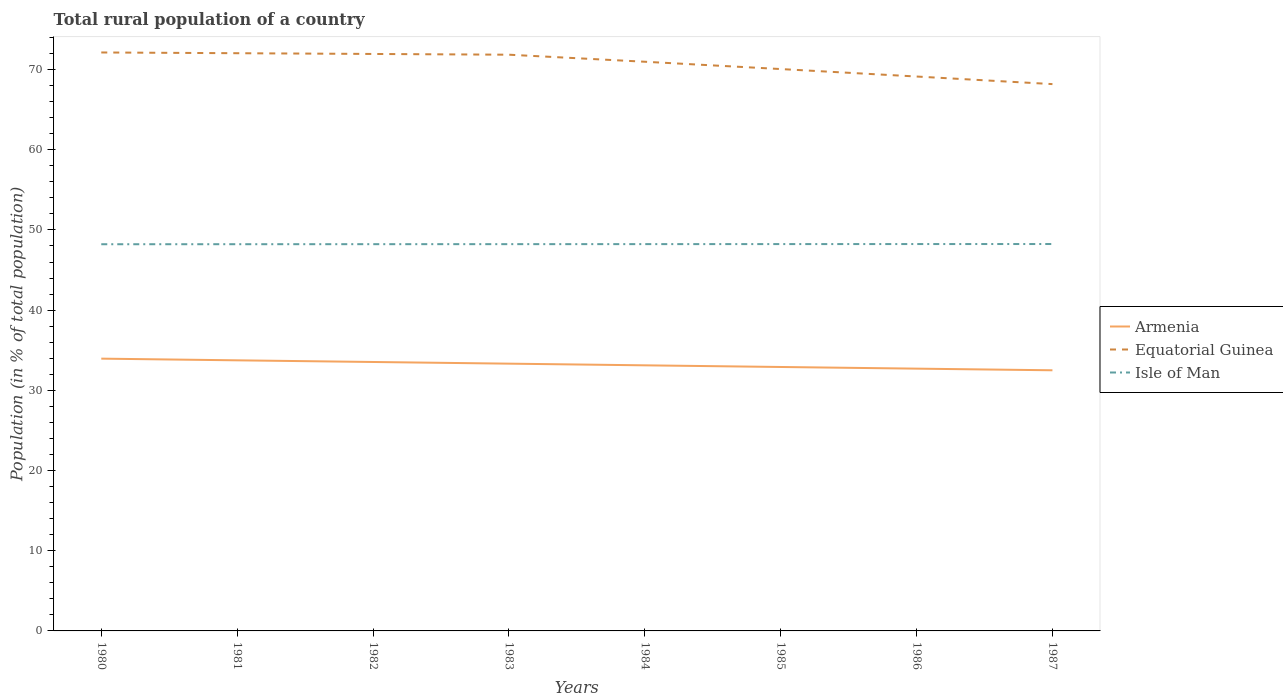How many different coloured lines are there?
Your response must be concise. 3. Does the line corresponding to Isle of Man intersect with the line corresponding to Armenia?
Keep it short and to the point. No. Across all years, what is the maximum rural population in Equatorial Guinea?
Give a very brief answer. 68.18. In which year was the rural population in Armenia maximum?
Your response must be concise. 1987. What is the total rural population in Armenia in the graph?
Your response must be concise. 0.62. What is the difference between the highest and the second highest rural population in Isle of Man?
Your answer should be compact. 0.03. What is the difference between the highest and the lowest rural population in Isle of Man?
Your answer should be very brief. 4. Is the rural population in Equatorial Guinea strictly greater than the rural population in Isle of Man over the years?
Offer a terse response. No. Are the values on the major ticks of Y-axis written in scientific E-notation?
Give a very brief answer. No. Does the graph contain any zero values?
Your answer should be compact. No. Where does the legend appear in the graph?
Your answer should be very brief. Center right. How many legend labels are there?
Provide a short and direct response. 3. How are the legend labels stacked?
Your answer should be very brief. Vertical. What is the title of the graph?
Provide a short and direct response. Total rural population of a country. Does "El Salvador" appear as one of the legend labels in the graph?
Provide a short and direct response. No. What is the label or title of the X-axis?
Provide a succinct answer. Years. What is the label or title of the Y-axis?
Provide a short and direct response. Population (in % of total population). What is the Population (in % of total population) in Armenia in 1980?
Offer a terse response. 33.95. What is the Population (in % of total population) in Equatorial Guinea in 1980?
Your answer should be very brief. 72.13. What is the Population (in % of total population) in Isle of Man in 1980?
Keep it short and to the point. 48.22. What is the Population (in % of total population) in Armenia in 1981?
Ensure brevity in your answer.  33.74. What is the Population (in % of total population) of Equatorial Guinea in 1981?
Provide a succinct answer. 72.03. What is the Population (in % of total population) in Isle of Man in 1981?
Provide a succinct answer. 48.22. What is the Population (in % of total population) of Armenia in 1982?
Offer a terse response. 33.53. What is the Population (in % of total population) of Equatorial Guinea in 1982?
Provide a succinct answer. 71.94. What is the Population (in % of total population) of Isle of Man in 1982?
Your answer should be very brief. 48.22. What is the Population (in % of total population) in Armenia in 1983?
Provide a short and direct response. 33.33. What is the Population (in % of total population) in Equatorial Guinea in 1983?
Offer a terse response. 71.85. What is the Population (in % of total population) of Isle of Man in 1983?
Offer a terse response. 48.23. What is the Population (in % of total population) in Armenia in 1984?
Make the answer very short. 33.12. What is the Population (in % of total population) in Equatorial Guinea in 1984?
Offer a terse response. 70.97. What is the Population (in % of total population) of Isle of Man in 1984?
Your answer should be compact. 48.23. What is the Population (in % of total population) of Armenia in 1985?
Provide a short and direct response. 32.91. What is the Population (in % of total population) in Equatorial Guinea in 1985?
Your response must be concise. 70.06. What is the Population (in % of total population) of Isle of Man in 1985?
Make the answer very short. 48.23. What is the Population (in % of total population) in Armenia in 1986?
Offer a terse response. 32.7. What is the Population (in % of total population) in Equatorial Guinea in 1986?
Make the answer very short. 69.13. What is the Population (in % of total population) of Isle of Man in 1986?
Give a very brief answer. 48.24. What is the Population (in % of total population) in Armenia in 1987?
Offer a very short reply. 32.5. What is the Population (in % of total population) of Equatorial Guinea in 1987?
Your answer should be compact. 68.18. What is the Population (in % of total population) of Isle of Man in 1987?
Make the answer very short. 48.24. Across all years, what is the maximum Population (in % of total population) of Armenia?
Provide a succinct answer. 33.95. Across all years, what is the maximum Population (in % of total population) in Equatorial Guinea?
Offer a terse response. 72.13. Across all years, what is the maximum Population (in % of total population) of Isle of Man?
Make the answer very short. 48.24. Across all years, what is the minimum Population (in % of total population) of Armenia?
Keep it short and to the point. 32.5. Across all years, what is the minimum Population (in % of total population) of Equatorial Guinea?
Your answer should be very brief. 68.18. Across all years, what is the minimum Population (in % of total population) in Isle of Man?
Your answer should be very brief. 48.22. What is the total Population (in % of total population) in Armenia in the graph?
Make the answer very short. 265.78. What is the total Population (in % of total population) in Equatorial Guinea in the graph?
Provide a succinct answer. 566.3. What is the total Population (in % of total population) in Isle of Man in the graph?
Your response must be concise. 385.83. What is the difference between the Population (in % of total population) of Armenia in 1980 and that in 1981?
Your answer should be compact. 0.21. What is the difference between the Population (in % of total population) of Equatorial Guinea in 1980 and that in 1981?
Keep it short and to the point. 0.09. What is the difference between the Population (in % of total population) in Isle of Man in 1980 and that in 1981?
Your response must be concise. -0. What is the difference between the Population (in % of total population) of Armenia in 1980 and that in 1982?
Offer a terse response. 0.42. What is the difference between the Population (in % of total population) of Equatorial Guinea in 1980 and that in 1982?
Your answer should be very brief. 0.19. What is the difference between the Population (in % of total population) in Isle of Man in 1980 and that in 1982?
Provide a succinct answer. -0.01. What is the difference between the Population (in % of total population) of Armenia in 1980 and that in 1983?
Give a very brief answer. 0.62. What is the difference between the Population (in % of total population) of Equatorial Guinea in 1980 and that in 1983?
Your answer should be very brief. 0.28. What is the difference between the Population (in % of total population) in Isle of Man in 1980 and that in 1983?
Your answer should be very brief. -0.01. What is the difference between the Population (in % of total population) in Armenia in 1980 and that in 1984?
Provide a succinct answer. 0.83. What is the difference between the Population (in % of total population) of Equatorial Guinea in 1980 and that in 1984?
Make the answer very short. 1.16. What is the difference between the Population (in % of total population) of Isle of Man in 1980 and that in 1984?
Give a very brief answer. -0.01. What is the difference between the Population (in % of total population) in Armenia in 1980 and that in 1985?
Make the answer very short. 1.04. What is the difference between the Population (in % of total population) of Equatorial Guinea in 1980 and that in 1985?
Your answer should be very brief. 2.07. What is the difference between the Population (in % of total population) in Isle of Man in 1980 and that in 1985?
Give a very brief answer. -0.02. What is the difference between the Population (in % of total population) in Armenia in 1980 and that in 1986?
Offer a terse response. 1.25. What is the difference between the Population (in % of total population) of Equatorial Guinea in 1980 and that in 1986?
Make the answer very short. 3. What is the difference between the Population (in % of total population) in Isle of Man in 1980 and that in 1986?
Your response must be concise. -0.02. What is the difference between the Population (in % of total population) in Armenia in 1980 and that in 1987?
Make the answer very short. 1.45. What is the difference between the Population (in % of total population) in Equatorial Guinea in 1980 and that in 1987?
Your answer should be very brief. 3.94. What is the difference between the Population (in % of total population) of Isle of Man in 1980 and that in 1987?
Make the answer very short. -0.03. What is the difference between the Population (in % of total population) in Armenia in 1981 and that in 1982?
Provide a succinct answer. 0.21. What is the difference between the Population (in % of total population) in Equatorial Guinea in 1981 and that in 1982?
Give a very brief answer. 0.09. What is the difference between the Population (in % of total population) in Isle of Man in 1981 and that in 1982?
Keep it short and to the point. -0. What is the difference between the Population (in % of total population) in Armenia in 1981 and that in 1983?
Ensure brevity in your answer.  0.42. What is the difference between the Population (in % of total population) of Equatorial Guinea in 1981 and that in 1983?
Offer a very short reply. 0.19. What is the difference between the Population (in % of total population) of Isle of Man in 1981 and that in 1983?
Keep it short and to the point. -0.01. What is the difference between the Population (in % of total population) of Armenia in 1981 and that in 1984?
Your answer should be very brief. 0.62. What is the difference between the Population (in % of total population) of Equatorial Guinea in 1981 and that in 1984?
Provide a short and direct response. 1.06. What is the difference between the Population (in % of total population) of Isle of Man in 1981 and that in 1984?
Provide a succinct answer. -0.01. What is the difference between the Population (in % of total population) of Armenia in 1981 and that in 1985?
Your response must be concise. 0.83. What is the difference between the Population (in % of total population) of Equatorial Guinea in 1981 and that in 1985?
Your answer should be very brief. 1.98. What is the difference between the Population (in % of total population) of Isle of Man in 1981 and that in 1985?
Keep it short and to the point. -0.01. What is the difference between the Population (in % of total population) in Armenia in 1981 and that in 1986?
Provide a short and direct response. 1.04. What is the difference between the Population (in % of total population) of Equatorial Guinea in 1981 and that in 1986?
Your answer should be compact. 2.91. What is the difference between the Population (in % of total population) in Isle of Man in 1981 and that in 1986?
Your answer should be compact. -0.02. What is the difference between the Population (in % of total population) in Armenia in 1981 and that in 1987?
Keep it short and to the point. 1.24. What is the difference between the Population (in % of total population) in Equatorial Guinea in 1981 and that in 1987?
Offer a very short reply. 3.85. What is the difference between the Population (in % of total population) in Isle of Man in 1981 and that in 1987?
Provide a succinct answer. -0.02. What is the difference between the Population (in % of total population) of Armenia in 1982 and that in 1983?
Ensure brevity in your answer.  0.21. What is the difference between the Population (in % of total population) in Equatorial Guinea in 1982 and that in 1983?
Your answer should be very brief. 0.09. What is the difference between the Population (in % of total population) in Isle of Man in 1982 and that in 1983?
Offer a very short reply. -0. What is the difference between the Population (in % of total population) of Armenia in 1982 and that in 1984?
Offer a terse response. 0.42. What is the difference between the Population (in % of total population) of Isle of Man in 1982 and that in 1984?
Your answer should be compact. -0.01. What is the difference between the Population (in % of total population) in Armenia in 1982 and that in 1985?
Your answer should be compact. 0.62. What is the difference between the Population (in % of total population) of Equatorial Guinea in 1982 and that in 1985?
Ensure brevity in your answer.  1.88. What is the difference between the Population (in % of total population) in Isle of Man in 1982 and that in 1985?
Your response must be concise. -0.01. What is the difference between the Population (in % of total population) in Armenia in 1982 and that in 1986?
Keep it short and to the point. 0.83. What is the difference between the Population (in % of total population) in Equatorial Guinea in 1982 and that in 1986?
Give a very brief answer. 2.81. What is the difference between the Population (in % of total population) in Isle of Man in 1982 and that in 1986?
Ensure brevity in your answer.  -0.01. What is the difference between the Population (in % of total population) of Armenia in 1982 and that in 1987?
Keep it short and to the point. 1.03. What is the difference between the Population (in % of total population) of Equatorial Guinea in 1982 and that in 1987?
Provide a succinct answer. 3.76. What is the difference between the Population (in % of total population) in Isle of Man in 1982 and that in 1987?
Your response must be concise. -0.02. What is the difference between the Population (in % of total population) of Armenia in 1983 and that in 1984?
Your answer should be very brief. 0.21. What is the difference between the Population (in % of total population) of Equatorial Guinea in 1983 and that in 1984?
Ensure brevity in your answer.  0.88. What is the difference between the Population (in % of total population) in Isle of Man in 1983 and that in 1984?
Your answer should be very brief. -0. What is the difference between the Population (in % of total population) of Armenia in 1983 and that in 1985?
Offer a very short reply. 0.41. What is the difference between the Population (in % of total population) of Equatorial Guinea in 1983 and that in 1985?
Provide a short and direct response. 1.79. What is the difference between the Population (in % of total population) of Isle of Man in 1983 and that in 1985?
Your answer should be very brief. -0.01. What is the difference between the Population (in % of total population) of Armenia in 1983 and that in 1986?
Offer a very short reply. 0.62. What is the difference between the Population (in % of total population) in Equatorial Guinea in 1983 and that in 1986?
Offer a very short reply. 2.72. What is the difference between the Population (in % of total population) of Isle of Man in 1983 and that in 1986?
Your response must be concise. -0.01. What is the difference between the Population (in % of total population) of Armenia in 1983 and that in 1987?
Provide a succinct answer. 0.83. What is the difference between the Population (in % of total population) in Equatorial Guinea in 1983 and that in 1987?
Keep it short and to the point. 3.67. What is the difference between the Population (in % of total population) of Isle of Man in 1983 and that in 1987?
Your answer should be compact. -0.02. What is the difference between the Population (in % of total population) in Armenia in 1984 and that in 1985?
Your answer should be very brief. 0.21. What is the difference between the Population (in % of total population) in Equatorial Guinea in 1984 and that in 1985?
Keep it short and to the point. 0.91. What is the difference between the Population (in % of total population) of Isle of Man in 1984 and that in 1985?
Ensure brevity in your answer.  -0. What is the difference between the Population (in % of total population) in Armenia in 1984 and that in 1986?
Your answer should be very brief. 0.41. What is the difference between the Population (in % of total population) of Equatorial Guinea in 1984 and that in 1986?
Your answer should be very brief. 1.84. What is the difference between the Population (in % of total population) in Isle of Man in 1984 and that in 1986?
Offer a very short reply. -0.01. What is the difference between the Population (in % of total population) of Armenia in 1984 and that in 1987?
Ensure brevity in your answer.  0.62. What is the difference between the Population (in % of total population) in Equatorial Guinea in 1984 and that in 1987?
Keep it short and to the point. 2.79. What is the difference between the Population (in % of total population) of Isle of Man in 1984 and that in 1987?
Give a very brief answer. -0.01. What is the difference between the Population (in % of total population) in Armenia in 1985 and that in 1986?
Offer a very short reply. 0.21. What is the difference between the Population (in % of total population) in Equatorial Guinea in 1985 and that in 1986?
Your answer should be compact. 0.93. What is the difference between the Population (in % of total population) in Isle of Man in 1985 and that in 1986?
Give a very brief answer. -0. What is the difference between the Population (in % of total population) in Armenia in 1985 and that in 1987?
Your answer should be very brief. 0.41. What is the difference between the Population (in % of total population) of Equatorial Guinea in 1985 and that in 1987?
Provide a succinct answer. 1.88. What is the difference between the Population (in % of total population) of Isle of Man in 1985 and that in 1987?
Keep it short and to the point. -0.01. What is the difference between the Population (in % of total population) of Armenia in 1986 and that in 1987?
Your answer should be very brief. 0.2. What is the difference between the Population (in % of total population) in Equatorial Guinea in 1986 and that in 1987?
Ensure brevity in your answer.  0.95. What is the difference between the Population (in % of total population) in Isle of Man in 1986 and that in 1987?
Keep it short and to the point. -0. What is the difference between the Population (in % of total population) of Armenia in 1980 and the Population (in % of total population) of Equatorial Guinea in 1981?
Your response must be concise. -38.09. What is the difference between the Population (in % of total population) in Armenia in 1980 and the Population (in % of total population) in Isle of Man in 1981?
Offer a terse response. -14.27. What is the difference between the Population (in % of total population) of Equatorial Guinea in 1980 and the Population (in % of total population) of Isle of Man in 1981?
Offer a terse response. 23.91. What is the difference between the Population (in % of total population) in Armenia in 1980 and the Population (in % of total population) in Equatorial Guinea in 1982?
Your answer should be compact. -37.99. What is the difference between the Population (in % of total population) of Armenia in 1980 and the Population (in % of total population) of Isle of Man in 1982?
Your response must be concise. -14.27. What is the difference between the Population (in % of total population) of Equatorial Guinea in 1980 and the Population (in % of total population) of Isle of Man in 1982?
Provide a succinct answer. 23.9. What is the difference between the Population (in % of total population) of Armenia in 1980 and the Population (in % of total population) of Equatorial Guinea in 1983?
Make the answer very short. -37.9. What is the difference between the Population (in % of total population) in Armenia in 1980 and the Population (in % of total population) in Isle of Man in 1983?
Ensure brevity in your answer.  -14.28. What is the difference between the Population (in % of total population) in Equatorial Guinea in 1980 and the Population (in % of total population) in Isle of Man in 1983?
Provide a short and direct response. 23.9. What is the difference between the Population (in % of total population) in Armenia in 1980 and the Population (in % of total population) in Equatorial Guinea in 1984?
Provide a short and direct response. -37.02. What is the difference between the Population (in % of total population) of Armenia in 1980 and the Population (in % of total population) of Isle of Man in 1984?
Provide a short and direct response. -14.28. What is the difference between the Population (in % of total population) of Equatorial Guinea in 1980 and the Population (in % of total population) of Isle of Man in 1984?
Keep it short and to the point. 23.9. What is the difference between the Population (in % of total population) of Armenia in 1980 and the Population (in % of total population) of Equatorial Guinea in 1985?
Ensure brevity in your answer.  -36.11. What is the difference between the Population (in % of total population) of Armenia in 1980 and the Population (in % of total population) of Isle of Man in 1985?
Give a very brief answer. -14.29. What is the difference between the Population (in % of total population) in Equatorial Guinea in 1980 and the Population (in % of total population) in Isle of Man in 1985?
Keep it short and to the point. 23.89. What is the difference between the Population (in % of total population) in Armenia in 1980 and the Population (in % of total population) in Equatorial Guinea in 1986?
Offer a terse response. -35.18. What is the difference between the Population (in % of total population) in Armenia in 1980 and the Population (in % of total population) in Isle of Man in 1986?
Provide a short and direct response. -14.29. What is the difference between the Population (in % of total population) of Equatorial Guinea in 1980 and the Population (in % of total population) of Isle of Man in 1986?
Your response must be concise. 23.89. What is the difference between the Population (in % of total population) of Armenia in 1980 and the Population (in % of total population) of Equatorial Guinea in 1987?
Provide a succinct answer. -34.23. What is the difference between the Population (in % of total population) in Armenia in 1980 and the Population (in % of total population) in Isle of Man in 1987?
Ensure brevity in your answer.  -14.29. What is the difference between the Population (in % of total population) of Equatorial Guinea in 1980 and the Population (in % of total population) of Isle of Man in 1987?
Ensure brevity in your answer.  23.89. What is the difference between the Population (in % of total population) in Armenia in 1981 and the Population (in % of total population) in Equatorial Guinea in 1982?
Make the answer very short. -38.2. What is the difference between the Population (in % of total population) of Armenia in 1981 and the Population (in % of total population) of Isle of Man in 1982?
Make the answer very short. -14.48. What is the difference between the Population (in % of total population) of Equatorial Guinea in 1981 and the Population (in % of total population) of Isle of Man in 1982?
Your response must be concise. 23.81. What is the difference between the Population (in % of total population) of Armenia in 1981 and the Population (in % of total population) of Equatorial Guinea in 1983?
Keep it short and to the point. -38.11. What is the difference between the Population (in % of total population) in Armenia in 1981 and the Population (in % of total population) in Isle of Man in 1983?
Your answer should be very brief. -14.49. What is the difference between the Population (in % of total population) in Equatorial Guinea in 1981 and the Population (in % of total population) in Isle of Man in 1983?
Provide a succinct answer. 23.81. What is the difference between the Population (in % of total population) of Armenia in 1981 and the Population (in % of total population) of Equatorial Guinea in 1984?
Ensure brevity in your answer.  -37.23. What is the difference between the Population (in % of total population) of Armenia in 1981 and the Population (in % of total population) of Isle of Man in 1984?
Give a very brief answer. -14.49. What is the difference between the Population (in % of total population) of Equatorial Guinea in 1981 and the Population (in % of total population) of Isle of Man in 1984?
Give a very brief answer. 23.8. What is the difference between the Population (in % of total population) in Armenia in 1981 and the Population (in % of total population) in Equatorial Guinea in 1985?
Provide a short and direct response. -36.32. What is the difference between the Population (in % of total population) of Armenia in 1981 and the Population (in % of total population) of Isle of Man in 1985?
Your answer should be very brief. -14.49. What is the difference between the Population (in % of total population) in Equatorial Guinea in 1981 and the Population (in % of total population) in Isle of Man in 1985?
Your response must be concise. 23.8. What is the difference between the Population (in % of total population) of Armenia in 1981 and the Population (in % of total population) of Equatorial Guinea in 1986?
Your answer should be very brief. -35.39. What is the difference between the Population (in % of total population) of Armenia in 1981 and the Population (in % of total population) of Isle of Man in 1986?
Offer a very short reply. -14.5. What is the difference between the Population (in % of total population) in Equatorial Guinea in 1981 and the Population (in % of total population) in Isle of Man in 1986?
Give a very brief answer. 23.8. What is the difference between the Population (in % of total population) of Armenia in 1981 and the Population (in % of total population) of Equatorial Guinea in 1987?
Your response must be concise. -34.44. What is the difference between the Population (in % of total population) in Armenia in 1981 and the Population (in % of total population) in Isle of Man in 1987?
Offer a terse response. -14.5. What is the difference between the Population (in % of total population) in Equatorial Guinea in 1981 and the Population (in % of total population) in Isle of Man in 1987?
Your answer should be very brief. 23.79. What is the difference between the Population (in % of total population) of Armenia in 1982 and the Population (in % of total population) of Equatorial Guinea in 1983?
Your response must be concise. -38.32. What is the difference between the Population (in % of total population) in Armenia in 1982 and the Population (in % of total population) in Isle of Man in 1983?
Ensure brevity in your answer.  -14.69. What is the difference between the Population (in % of total population) in Equatorial Guinea in 1982 and the Population (in % of total population) in Isle of Man in 1983?
Give a very brief answer. 23.71. What is the difference between the Population (in % of total population) in Armenia in 1982 and the Population (in % of total population) in Equatorial Guinea in 1984?
Offer a terse response. -37.44. What is the difference between the Population (in % of total population) in Armenia in 1982 and the Population (in % of total population) in Isle of Man in 1984?
Offer a very short reply. -14.7. What is the difference between the Population (in % of total population) in Equatorial Guinea in 1982 and the Population (in % of total population) in Isle of Man in 1984?
Provide a short and direct response. 23.71. What is the difference between the Population (in % of total population) of Armenia in 1982 and the Population (in % of total population) of Equatorial Guinea in 1985?
Provide a short and direct response. -36.53. What is the difference between the Population (in % of total population) in Armenia in 1982 and the Population (in % of total population) in Isle of Man in 1985?
Your answer should be compact. -14.7. What is the difference between the Population (in % of total population) in Equatorial Guinea in 1982 and the Population (in % of total population) in Isle of Man in 1985?
Your answer should be very brief. 23.71. What is the difference between the Population (in % of total population) of Armenia in 1982 and the Population (in % of total population) of Equatorial Guinea in 1986?
Provide a short and direct response. -35.6. What is the difference between the Population (in % of total population) of Armenia in 1982 and the Population (in % of total population) of Isle of Man in 1986?
Ensure brevity in your answer.  -14.71. What is the difference between the Population (in % of total population) of Equatorial Guinea in 1982 and the Population (in % of total population) of Isle of Man in 1986?
Provide a short and direct response. 23.7. What is the difference between the Population (in % of total population) of Armenia in 1982 and the Population (in % of total population) of Equatorial Guinea in 1987?
Ensure brevity in your answer.  -34.65. What is the difference between the Population (in % of total population) of Armenia in 1982 and the Population (in % of total population) of Isle of Man in 1987?
Your answer should be very brief. -14.71. What is the difference between the Population (in % of total population) in Equatorial Guinea in 1982 and the Population (in % of total population) in Isle of Man in 1987?
Give a very brief answer. 23.7. What is the difference between the Population (in % of total population) of Armenia in 1983 and the Population (in % of total population) of Equatorial Guinea in 1984?
Your response must be concise. -37.65. What is the difference between the Population (in % of total population) of Armenia in 1983 and the Population (in % of total population) of Isle of Man in 1984?
Offer a very short reply. -14.91. What is the difference between the Population (in % of total population) in Equatorial Guinea in 1983 and the Population (in % of total population) in Isle of Man in 1984?
Your response must be concise. 23.62. What is the difference between the Population (in % of total population) in Armenia in 1983 and the Population (in % of total population) in Equatorial Guinea in 1985?
Keep it short and to the point. -36.73. What is the difference between the Population (in % of total population) in Armenia in 1983 and the Population (in % of total population) in Isle of Man in 1985?
Make the answer very short. -14.91. What is the difference between the Population (in % of total population) in Equatorial Guinea in 1983 and the Population (in % of total population) in Isle of Man in 1985?
Your answer should be very brief. 23.61. What is the difference between the Population (in % of total population) of Armenia in 1983 and the Population (in % of total population) of Equatorial Guinea in 1986?
Keep it short and to the point. -35.8. What is the difference between the Population (in % of total population) in Armenia in 1983 and the Population (in % of total population) in Isle of Man in 1986?
Make the answer very short. -14.91. What is the difference between the Population (in % of total population) in Equatorial Guinea in 1983 and the Population (in % of total population) in Isle of Man in 1986?
Offer a very short reply. 23.61. What is the difference between the Population (in % of total population) of Armenia in 1983 and the Population (in % of total population) of Equatorial Guinea in 1987?
Your answer should be very brief. -34.86. What is the difference between the Population (in % of total population) of Armenia in 1983 and the Population (in % of total population) of Isle of Man in 1987?
Provide a short and direct response. -14.92. What is the difference between the Population (in % of total population) in Equatorial Guinea in 1983 and the Population (in % of total population) in Isle of Man in 1987?
Offer a very short reply. 23.61. What is the difference between the Population (in % of total population) of Armenia in 1984 and the Population (in % of total population) of Equatorial Guinea in 1985?
Ensure brevity in your answer.  -36.94. What is the difference between the Population (in % of total population) of Armenia in 1984 and the Population (in % of total population) of Isle of Man in 1985?
Your answer should be very brief. -15.12. What is the difference between the Population (in % of total population) in Equatorial Guinea in 1984 and the Population (in % of total population) in Isle of Man in 1985?
Make the answer very short. 22.74. What is the difference between the Population (in % of total population) of Armenia in 1984 and the Population (in % of total population) of Equatorial Guinea in 1986?
Your answer should be very brief. -36.01. What is the difference between the Population (in % of total population) in Armenia in 1984 and the Population (in % of total population) in Isle of Man in 1986?
Ensure brevity in your answer.  -15.12. What is the difference between the Population (in % of total population) in Equatorial Guinea in 1984 and the Population (in % of total population) in Isle of Man in 1986?
Offer a very short reply. 22.73. What is the difference between the Population (in % of total population) of Armenia in 1984 and the Population (in % of total population) of Equatorial Guinea in 1987?
Make the answer very short. -35.07. What is the difference between the Population (in % of total population) in Armenia in 1984 and the Population (in % of total population) in Isle of Man in 1987?
Offer a terse response. -15.13. What is the difference between the Population (in % of total population) of Equatorial Guinea in 1984 and the Population (in % of total population) of Isle of Man in 1987?
Your answer should be compact. 22.73. What is the difference between the Population (in % of total population) of Armenia in 1985 and the Population (in % of total population) of Equatorial Guinea in 1986?
Ensure brevity in your answer.  -36.22. What is the difference between the Population (in % of total population) of Armenia in 1985 and the Population (in % of total population) of Isle of Man in 1986?
Make the answer very short. -15.33. What is the difference between the Population (in % of total population) of Equatorial Guinea in 1985 and the Population (in % of total population) of Isle of Man in 1986?
Your answer should be very brief. 21.82. What is the difference between the Population (in % of total population) of Armenia in 1985 and the Population (in % of total population) of Equatorial Guinea in 1987?
Provide a succinct answer. -35.27. What is the difference between the Population (in % of total population) in Armenia in 1985 and the Population (in % of total population) in Isle of Man in 1987?
Your response must be concise. -15.33. What is the difference between the Population (in % of total population) of Equatorial Guinea in 1985 and the Population (in % of total population) of Isle of Man in 1987?
Offer a terse response. 21.82. What is the difference between the Population (in % of total population) in Armenia in 1986 and the Population (in % of total population) in Equatorial Guinea in 1987?
Offer a terse response. -35.48. What is the difference between the Population (in % of total population) of Armenia in 1986 and the Population (in % of total population) of Isle of Man in 1987?
Ensure brevity in your answer.  -15.54. What is the difference between the Population (in % of total population) in Equatorial Guinea in 1986 and the Population (in % of total population) in Isle of Man in 1987?
Your response must be concise. 20.89. What is the average Population (in % of total population) in Armenia per year?
Your answer should be compact. 33.22. What is the average Population (in % of total population) in Equatorial Guinea per year?
Provide a succinct answer. 70.79. What is the average Population (in % of total population) in Isle of Man per year?
Ensure brevity in your answer.  48.23. In the year 1980, what is the difference between the Population (in % of total population) in Armenia and Population (in % of total population) in Equatorial Guinea?
Ensure brevity in your answer.  -38.18. In the year 1980, what is the difference between the Population (in % of total population) of Armenia and Population (in % of total population) of Isle of Man?
Offer a very short reply. -14.27. In the year 1980, what is the difference between the Population (in % of total population) of Equatorial Guinea and Population (in % of total population) of Isle of Man?
Offer a very short reply. 23.91. In the year 1981, what is the difference between the Population (in % of total population) of Armenia and Population (in % of total population) of Equatorial Guinea?
Your answer should be very brief. -38.29. In the year 1981, what is the difference between the Population (in % of total population) of Armenia and Population (in % of total population) of Isle of Man?
Give a very brief answer. -14.48. In the year 1981, what is the difference between the Population (in % of total population) of Equatorial Guinea and Population (in % of total population) of Isle of Man?
Provide a succinct answer. 23.82. In the year 1982, what is the difference between the Population (in % of total population) of Armenia and Population (in % of total population) of Equatorial Guinea?
Ensure brevity in your answer.  -38.41. In the year 1982, what is the difference between the Population (in % of total population) in Armenia and Population (in % of total population) in Isle of Man?
Make the answer very short. -14.69. In the year 1982, what is the difference between the Population (in % of total population) in Equatorial Guinea and Population (in % of total population) in Isle of Man?
Your answer should be very brief. 23.72. In the year 1983, what is the difference between the Population (in % of total population) of Armenia and Population (in % of total population) of Equatorial Guinea?
Offer a terse response. -38.52. In the year 1983, what is the difference between the Population (in % of total population) in Armenia and Population (in % of total population) in Isle of Man?
Provide a succinct answer. -14.9. In the year 1983, what is the difference between the Population (in % of total population) in Equatorial Guinea and Population (in % of total population) in Isle of Man?
Provide a succinct answer. 23.62. In the year 1984, what is the difference between the Population (in % of total population) of Armenia and Population (in % of total population) of Equatorial Guinea?
Your response must be concise. -37.85. In the year 1984, what is the difference between the Population (in % of total population) in Armenia and Population (in % of total population) in Isle of Man?
Offer a terse response. -15.11. In the year 1984, what is the difference between the Population (in % of total population) of Equatorial Guinea and Population (in % of total population) of Isle of Man?
Provide a short and direct response. 22.74. In the year 1985, what is the difference between the Population (in % of total population) of Armenia and Population (in % of total population) of Equatorial Guinea?
Keep it short and to the point. -37.15. In the year 1985, what is the difference between the Population (in % of total population) of Armenia and Population (in % of total population) of Isle of Man?
Your answer should be very brief. -15.32. In the year 1985, what is the difference between the Population (in % of total population) in Equatorial Guinea and Population (in % of total population) in Isle of Man?
Provide a short and direct response. 21.82. In the year 1986, what is the difference between the Population (in % of total population) of Armenia and Population (in % of total population) of Equatorial Guinea?
Provide a short and direct response. -36.42. In the year 1986, what is the difference between the Population (in % of total population) of Armenia and Population (in % of total population) of Isle of Man?
Keep it short and to the point. -15.54. In the year 1986, what is the difference between the Population (in % of total population) in Equatorial Guinea and Population (in % of total population) in Isle of Man?
Your answer should be compact. 20.89. In the year 1987, what is the difference between the Population (in % of total population) in Armenia and Population (in % of total population) in Equatorial Guinea?
Provide a succinct answer. -35.68. In the year 1987, what is the difference between the Population (in % of total population) in Armenia and Population (in % of total population) in Isle of Man?
Ensure brevity in your answer.  -15.74. In the year 1987, what is the difference between the Population (in % of total population) of Equatorial Guinea and Population (in % of total population) of Isle of Man?
Give a very brief answer. 19.94. What is the ratio of the Population (in % of total population) of Armenia in 1980 to that in 1981?
Offer a terse response. 1.01. What is the ratio of the Population (in % of total population) in Isle of Man in 1980 to that in 1981?
Your response must be concise. 1. What is the ratio of the Population (in % of total population) of Armenia in 1980 to that in 1982?
Offer a very short reply. 1.01. What is the ratio of the Population (in % of total population) of Armenia in 1980 to that in 1983?
Make the answer very short. 1.02. What is the ratio of the Population (in % of total population) in Isle of Man in 1980 to that in 1983?
Give a very brief answer. 1. What is the ratio of the Population (in % of total population) of Armenia in 1980 to that in 1984?
Offer a terse response. 1.03. What is the ratio of the Population (in % of total population) in Equatorial Guinea in 1980 to that in 1984?
Offer a very short reply. 1.02. What is the ratio of the Population (in % of total population) in Isle of Man in 1980 to that in 1984?
Your answer should be very brief. 1. What is the ratio of the Population (in % of total population) of Armenia in 1980 to that in 1985?
Your answer should be compact. 1.03. What is the ratio of the Population (in % of total population) of Equatorial Guinea in 1980 to that in 1985?
Offer a very short reply. 1.03. What is the ratio of the Population (in % of total population) of Armenia in 1980 to that in 1986?
Provide a short and direct response. 1.04. What is the ratio of the Population (in % of total population) in Equatorial Guinea in 1980 to that in 1986?
Offer a very short reply. 1.04. What is the ratio of the Population (in % of total population) of Isle of Man in 1980 to that in 1986?
Provide a succinct answer. 1. What is the ratio of the Population (in % of total population) of Armenia in 1980 to that in 1987?
Offer a terse response. 1.04. What is the ratio of the Population (in % of total population) in Equatorial Guinea in 1980 to that in 1987?
Give a very brief answer. 1.06. What is the ratio of the Population (in % of total population) in Isle of Man in 1980 to that in 1987?
Give a very brief answer. 1. What is the ratio of the Population (in % of total population) in Isle of Man in 1981 to that in 1982?
Your answer should be very brief. 1. What is the ratio of the Population (in % of total population) of Armenia in 1981 to that in 1983?
Your response must be concise. 1.01. What is the ratio of the Population (in % of total population) of Equatorial Guinea in 1981 to that in 1983?
Keep it short and to the point. 1. What is the ratio of the Population (in % of total population) of Armenia in 1981 to that in 1984?
Make the answer very short. 1.02. What is the ratio of the Population (in % of total population) in Equatorial Guinea in 1981 to that in 1984?
Offer a very short reply. 1.01. What is the ratio of the Population (in % of total population) in Isle of Man in 1981 to that in 1984?
Your response must be concise. 1. What is the ratio of the Population (in % of total population) in Armenia in 1981 to that in 1985?
Ensure brevity in your answer.  1.03. What is the ratio of the Population (in % of total population) in Equatorial Guinea in 1981 to that in 1985?
Give a very brief answer. 1.03. What is the ratio of the Population (in % of total population) in Isle of Man in 1981 to that in 1985?
Offer a terse response. 1. What is the ratio of the Population (in % of total population) in Armenia in 1981 to that in 1986?
Give a very brief answer. 1.03. What is the ratio of the Population (in % of total population) of Equatorial Guinea in 1981 to that in 1986?
Make the answer very short. 1.04. What is the ratio of the Population (in % of total population) in Armenia in 1981 to that in 1987?
Offer a very short reply. 1.04. What is the ratio of the Population (in % of total population) of Equatorial Guinea in 1981 to that in 1987?
Provide a short and direct response. 1.06. What is the ratio of the Population (in % of total population) of Isle of Man in 1981 to that in 1987?
Offer a very short reply. 1. What is the ratio of the Population (in % of total population) of Equatorial Guinea in 1982 to that in 1983?
Your answer should be very brief. 1. What is the ratio of the Population (in % of total population) of Isle of Man in 1982 to that in 1983?
Keep it short and to the point. 1. What is the ratio of the Population (in % of total population) in Armenia in 1982 to that in 1984?
Your answer should be compact. 1.01. What is the ratio of the Population (in % of total population) in Equatorial Guinea in 1982 to that in 1984?
Your response must be concise. 1.01. What is the ratio of the Population (in % of total population) of Armenia in 1982 to that in 1985?
Your answer should be compact. 1.02. What is the ratio of the Population (in % of total population) in Equatorial Guinea in 1982 to that in 1985?
Ensure brevity in your answer.  1.03. What is the ratio of the Population (in % of total population) of Armenia in 1982 to that in 1986?
Provide a succinct answer. 1.03. What is the ratio of the Population (in % of total population) of Equatorial Guinea in 1982 to that in 1986?
Offer a terse response. 1.04. What is the ratio of the Population (in % of total population) in Armenia in 1982 to that in 1987?
Keep it short and to the point. 1.03. What is the ratio of the Population (in % of total population) of Equatorial Guinea in 1982 to that in 1987?
Give a very brief answer. 1.06. What is the ratio of the Population (in % of total population) in Armenia in 1983 to that in 1984?
Offer a terse response. 1.01. What is the ratio of the Population (in % of total population) of Equatorial Guinea in 1983 to that in 1984?
Offer a terse response. 1.01. What is the ratio of the Population (in % of total population) of Armenia in 1983 to that in 1985?
Your response must be concise. 1.01. What is the ratio of the Population (in % of total population) of Equatorial Guinea in 1983 to that in 1985?
Your response must be concise. 1.03. What is the ratio of the Population (in % of total population) of Equatorial Guinea in 1983 to that in 1986?
Provide a short and direct response. 1.04. What is the ratio of the Population (in % of total population) in Armenia in 1983 to that in 1987?
Offer a terse response. 1.03. What is the ratio of the Population (in % of total population) in Equatorial Guinea in 1983 to that in 1987?
Make the answer very short. 1.05. What is the ratio of the Population (in % of total population) in Armenia in 1984 to that in 1985?
Offer a terse response. 1.01. What is the ratio of the Population (in % of total population) of Equatorial Guinea in 1984 to that in 1985?
Offer a very short reply. 1.01. What is the ratio of the Population (in % of total population) in Isle of Man in 1984 to that in 1985?
Your response must be concise. 1. What is the ratio of the Population (in % of total population) in Armenia in 1984 to that in 1986?
Provide a short and direct response. 1.01. What is the ratio of the Population (in % of total population) in Equatorial Guinea in 1984 to that in 1986?
Offer a terse response. 1.03. What is the ratio of the Population (in % of total population) in Equatorial Guinea in 1984 to that in 1987?
Your answer should be very brief. 1.04. What is the ratio of the Population (in % of total population) in Isle of Man in 1984 to that in 1987?
Your answer should be very brief. 1. What is the ratio of the Population (in % of total population) in Equatorial Guinea in 1985 to that in 1986?
Keep it short and to the point. 1.01. What is the ratio of the Population (in % of total population) in Isle of Man in 1985 to that in 1986?
Provide a short and direct response. 1. What is the ratio of the Population (in % of total population) in Armenia in 1985 to that in 1987?
Your answer should be compact. 1.01. What is the ratio of the Population (in % of total population) of Equatorial Guinea in 1985 to that in 1987?
Your response must be concise. 1.03. What is the ratio of the Population (in % of total population) of Armenia in 1986 to that in 1987?
Provide a succinct answer. 1.01. What is the ratio of the Population (in % of total population) of Equatorial Guinea in 1986 to that in 1987?
Keep it short and to the point. 1.01. What is the ratio of the Population (in % of total population) of Isle of Man in 1986 to that in 1987?
Offer a terse response. 1. What is the difference between the highest and the second highest Population (in % of total population) in Armenia?
Your answer should be very brief. 0.21. What is the difference between the highest and the second highest Population (in % of total population) in Equatorial Guinea?
Give a very brief answer. 0.09. What is the difference between the highest and the second highest Population (in % of total population) of Isle of Man?
Your answer should be very brief. 0. What is the difference between the highest and the lowest Population (in % of total population) of Armenia?
Make the answer very short. 1.45. What is the difference between the highest and the lowest Population (in % of total population) of Equatorial Guinea?
Your answer should be very brief. 3.94. What is the difference between the highest and the lowest Population (in % of total population) of Isle of Man?
Provide a short and direct response. 0.03. 